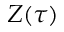Convert formula to latex. <formula><loc_0><loc_0><loc_500><loc_500>Z ( \tau )</formula> 